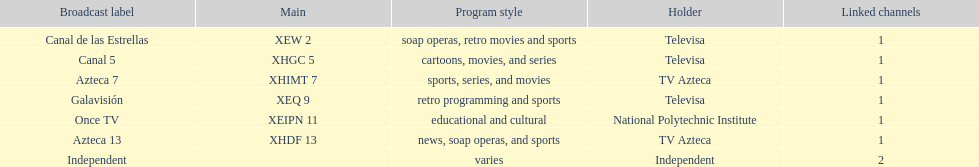Name a station that shows sports but is not televisa. Azteca 7. 